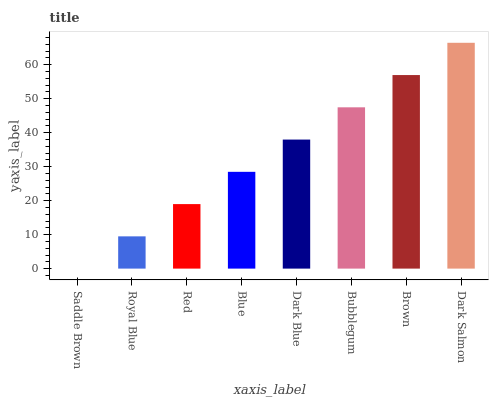Is Dark Salmon the maximum?
Answer yes or no. Yes. Is Royal Blue the minimum?
Answer yes or no. No. Is Royal Blue the maximum?
Answer yes or no. No. Is Royal Blue greater than Saddle Brown?
Answer yes or no. Yes. Is Saddle Brown less than Royal Blue?
Answer yes or no. Yes. Is Saddle Brown greater than Royal Blue?
Answer yes or no. No. Is Royal Blue less than Saddle Brown?
Answer yes or no. No. Is Dark Blue the high median?
Answer yes or no. Yes. Is Blue the low median?
Answer yes or no. Yes. Is Brown the high median?
Answer yes or no. No. Is Bubblegum the low median?
Answer yes or no. No. 